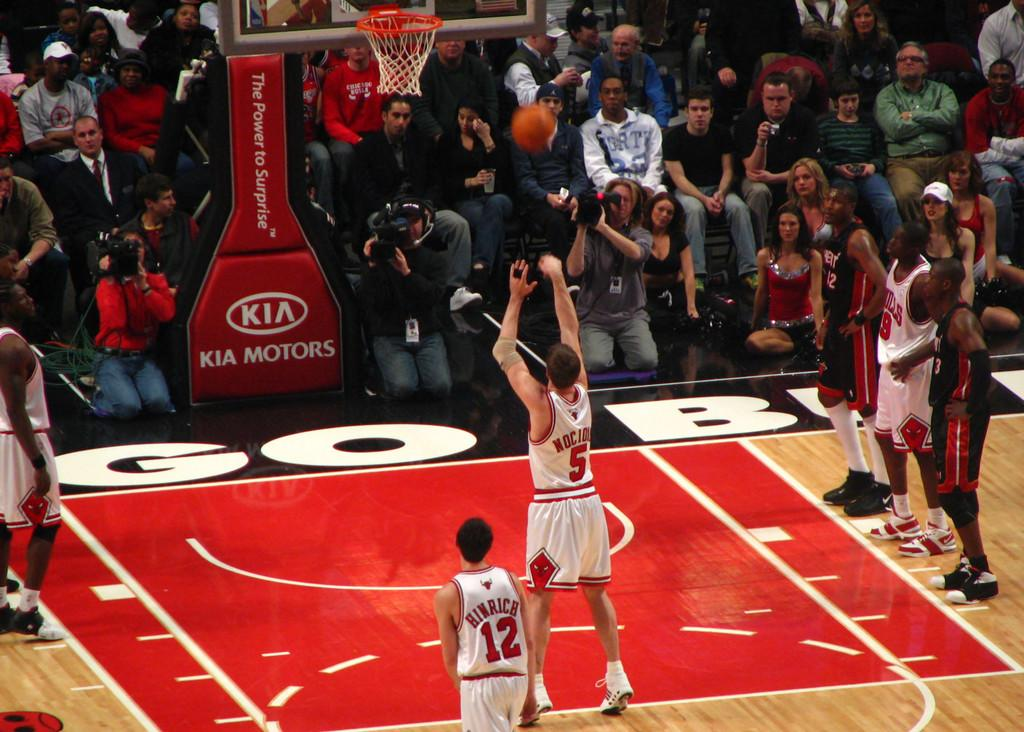<image>
Share a concise interpretation of the image provided. a player shooting a ball and another person with the number 12 on 